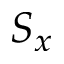Convert formula to latex. <formula><loc_0><loc_0><loc_500><loc_500>S _ { x }</formula> 